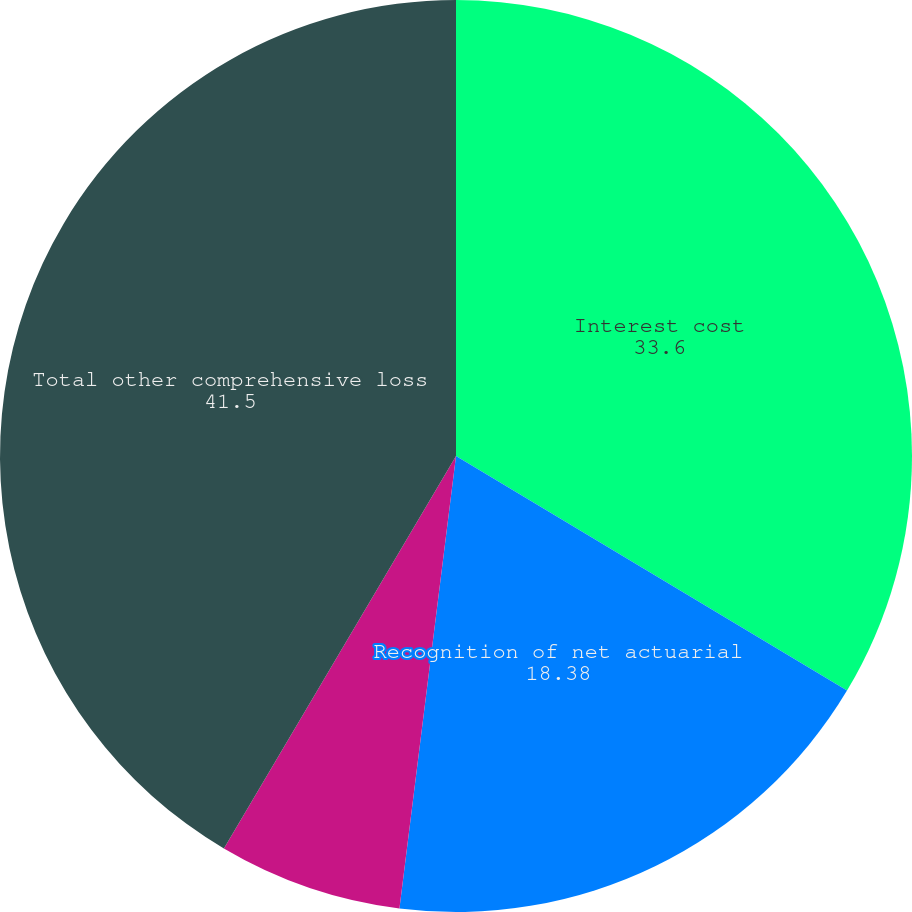Convert chart. <chart><loc_0><loc_0><loc_500><loc_500><pie_chart><fcel>Interest cost<fcel>Recognition of net actuarial<fcel>Recognition of prior service<fcel>Total other comprehensive loss<nl><fcel>33.6%<fcel>18.38%<fcel>6.52%<fcel>41.5%<nl></chart> 